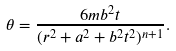Convert formula to latex. <formula><loc_0><loc_0><loc_500><loc_500>\theta = \frac { 6 m b ^ { 2 } t } { ( r ^ { 2 } + a ^ { 2 } + b ^ { 2 } t ^ { 2 } ) ^ { n + 1 } } .</formula> 